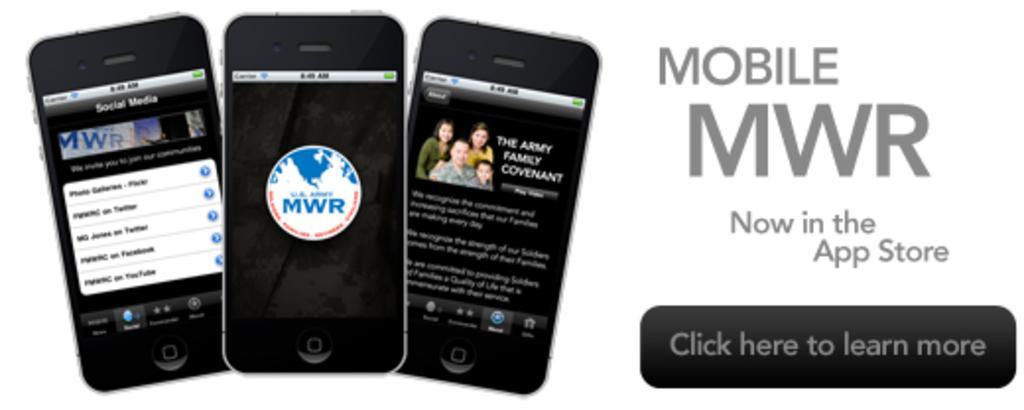Please provide a concise description of this image. In this image I can see few mobiles and I can see something written on the image and the background is in white color. 